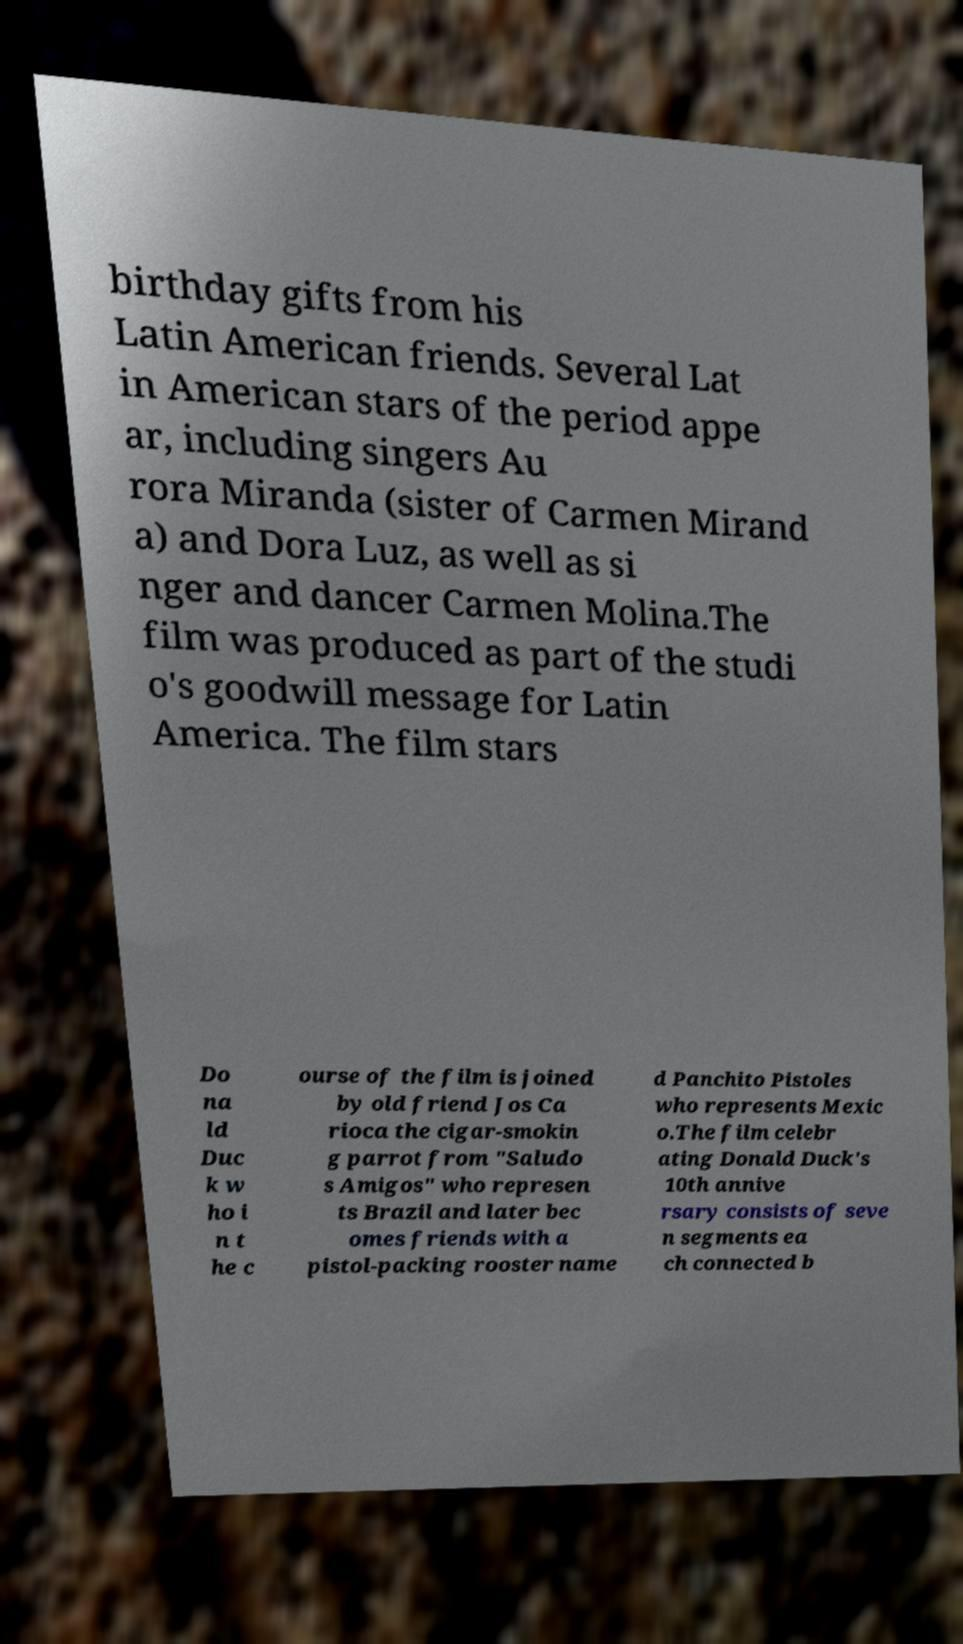Can you accurately transcribe the text from the provided image for me? birthday gifts from his Latin American friends. Several Lat in American stars of the period appe ar, including singers Au rora Miranda (sister of Carmen Mirand a) and Dora Luz, as well as si nger and dancer Carmen Molina.The film was produced as part of the studi o's goodwill message for Latin America. The film stars Do na ld Duc k w ho i n t he c ourse of the film is joined by old friend Jos Ca rioca the cigar-smokin g parrot from "Saludo s Amigos" who represen ts Brazil and later bec omes friends with a pistol-packing rooster name d Panchito Pistoles who represents Mexic o.The film celebr ating Donald Duck's 10th annive rsary consists of seve n segments ea ch connected b 